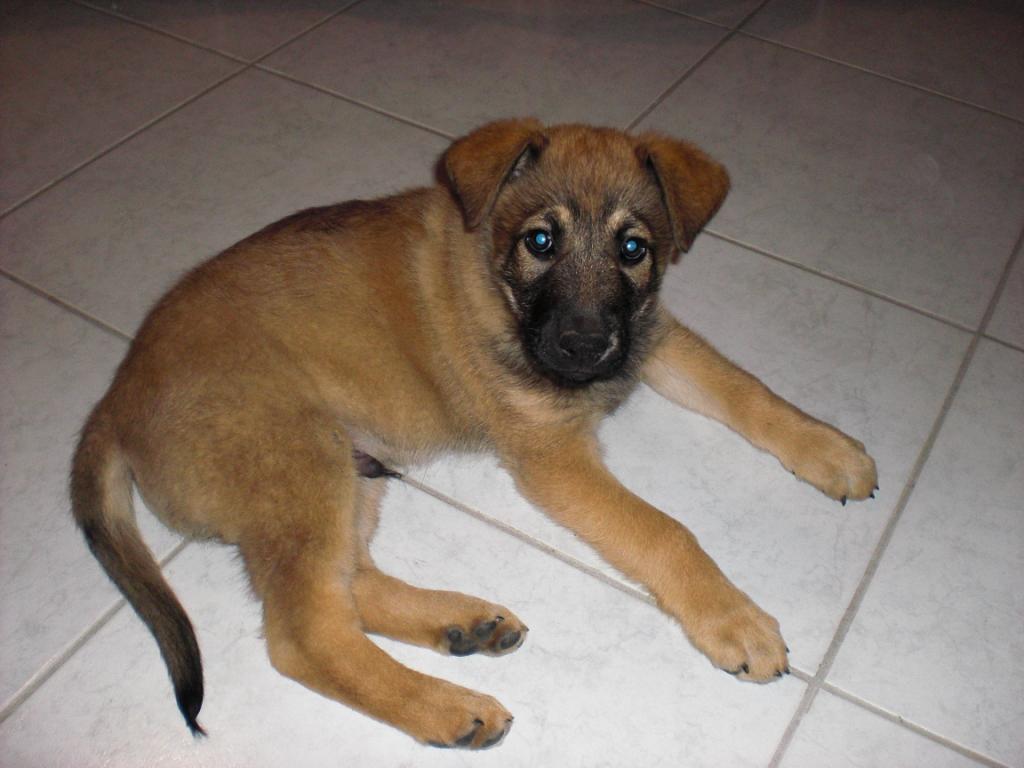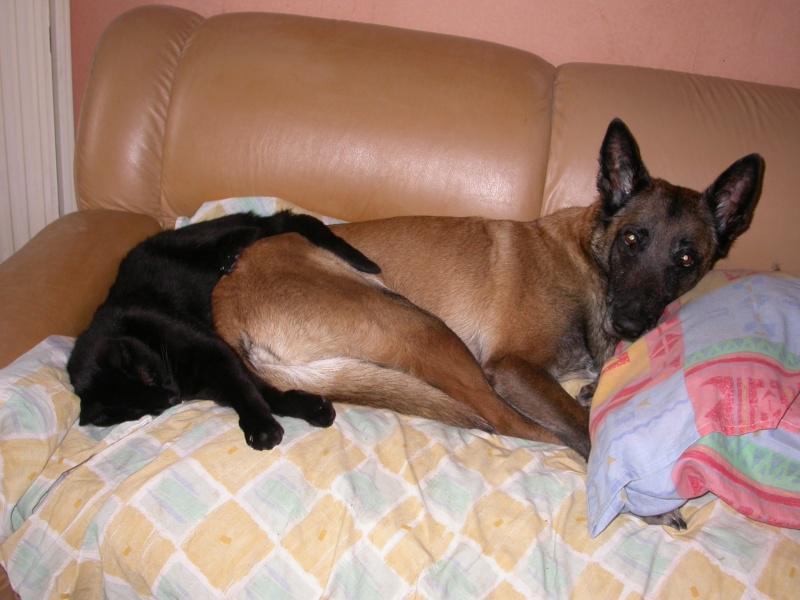The first image is the image on the left, the second image is the image on the right. Given the left and right images, does the statement "An image shows a dog and a cat together in a resting pose." hold true? Answer yes or no. Yes. The first image is the image on the left, the second image is the image on the right. Given the left and right images, does the statement "A dog and a cat are lying down together." hold true? Answer yes or no. Yes. 